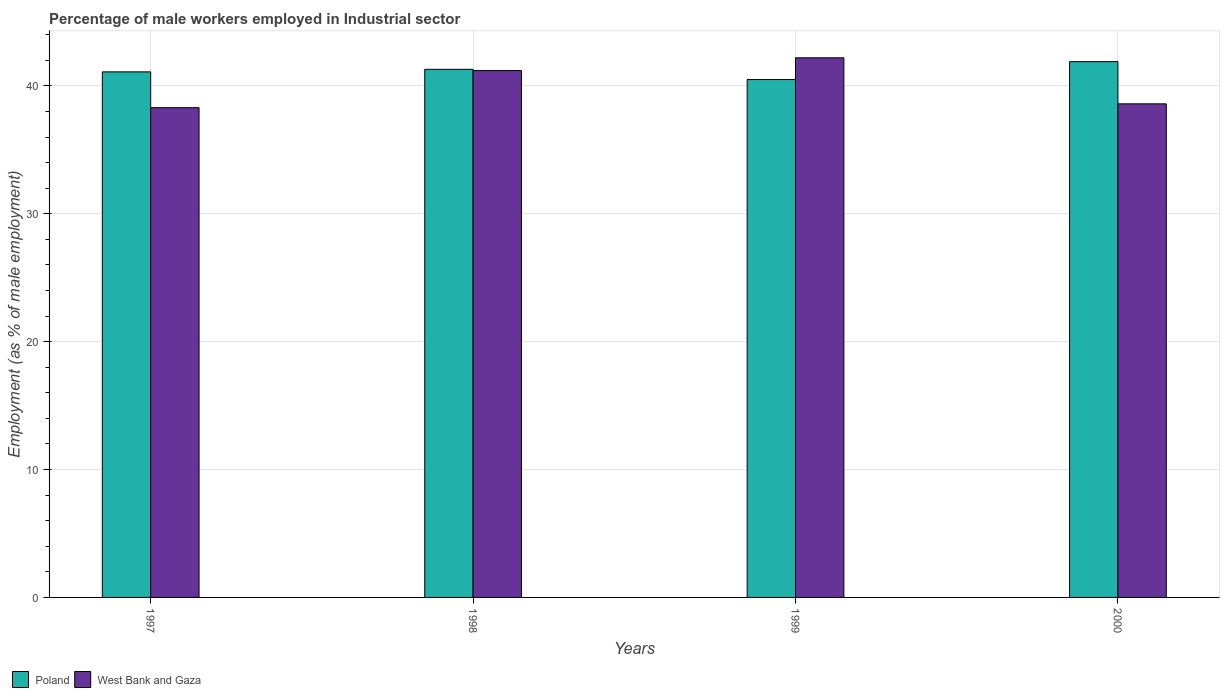Are the number of bars on each tick of the X-axis equal?
Offer a very short reply. Yes. How many bars are there on the 2nd tick from the left?
Give a very brief answer. 2. How many bars are there on the 3rd tick from the right?
Your answer should be compact. 2. In how many cases, is the number of bars for a given year not equal to the number of legend labels?
Your response must be concise. 0. What is the percentage of male workers employed in Industrial sector in West Bank and Gaza in 1999?
Provide a short and direct response. 42.2. Across all years, what is the maximum percentage of male workers employed in Industrial sector in West Bank and Gaza?
Your answer should be very brief. 42.2. Across all years, what is the minimum percentage of male workers employed in Industrial sector in West Bank and Gaza?
Give a very brief answer. 38.3. In which year was the percentage of male workers employed in Industrial sector in West Bank and Gaza maximum?
Make the answer very short. 1999. In which year was the percentage of male workers employed in Industrial sector in West Bank and Gaza minimum?
Keep it short and to the point. 1997. What is the total percentage of male workers employed in Industrial sector in West Bank and Gaza in the graph?
Make the answer very short. 160.3. What is the difference between the percentage of male workers employed in Industrial sector in West Bank and Gaza in 1999 and that in 2000?
Ensure brevity in your answer.  3.6. What is the difference between the percentage of male workers employed in Industrial sector in Poland in 1998 and the percentage of male workers employed in Industrial sector in West Bank and Gaza in 1997?
Ensure brevity in your answer.  3. What is the average percentage of male workers employed in Industrial sector in West Bank and Gaza per year?
Give a very brief answer. 40.07. In the year 2000, what is the difference between the percentage of male workers employed in Industrial sector in Poland and percentage of male workers employed in Industrial sector in West Bank and Gaza?
Your answer should be compact. 3.3. In how many years, is the percentage of male workers employed in Industrial sector in West Bank and Gaza greater than 14 %?
Make the answer very short. 4. What is the ratio of the percentage of male workers employed in Industrial sector in Poland in 1998 to that in 1999?
Provide a succinct answer. 1.02. Is the percentage of male workers employed in Industrial sector in Poland in 1997 less than that in 1998?
Offer a terse response. Yes. Is the difference between the percentage of male workers employed in Industrial sector in Poland in 1997 and 2000 greater than the difference between the percentage of male workers employed in Industrial sector in West Bank and Gaza in 1997 and 2000?
Keep it short and to the point. No. What is the difference between the highest and the lowest percentage of male workers employed in Industrial sector in West Bank and Gaza?
Give a very brief answer. 3.9. In how many years, is the percentage of male workers employed in Industrial sector in West Bank and Gaza greater than the average percentage of male workers employed in Industrial sector in West Bank and Gaza taken over all years?
Your response must be concise. 2. What does the 1st bar from the right in 1999 represents?
Keep it short and to the point. West Bank and Gaza. How many bars are there?
Your answer should be very brief. 8. Are all the bars in the graph horizontal?
Give a very brief answer. No. How many years are there in the graph?
Provide a short and direct response. 4. What is the difference between two consecutive major ticks on the Y-axis?
Your response must be concise. 10. Does the graph contain grids?
Provide a short and direct response. Yes. How are the legend labels stacked?
Your answer should be very brief. Horizontal. What is the title of the graph?
Your response must be concise. Percentage of male workers employed in Industrial sector. Does "San Marino" appear as one of the legend labels in the graph?
Provide a succinct answer. No. What is the label or title of the X-axis?
Keep it short and to the point. Years. What is the label or title of the Y-axis?
Ensure brevity in your answer.  Employment (as % of male employment). What is the Employment (as % of male employment) of Poland in 1997?
Your answer should be compact. 41.1. What is the Employment (as % of male employment) in West Bank and Gaza in 1997?
Give a very brief answer. 38.3. What is the Employment (as % of male employment) of Poland in 1998?
Offer a very short reply. 41.3. What is the Employment (as % of male employment) of West Bank and Gaza in 1998?
Provide a short and direct response. 41.2. What is the Employment (as % of male employment) of Poland in 1999?
Your response must be concise. 40.5. What is the Employment (as % of male employment) in West Bank and Gaza in 1999?
Give a very brief answer. 42.2. What is the Employment (as % of male employment) of Poland in 2000?
Your answer should be very brief. 41.9. What is the Employment (as % of male employment) in West Bank and Gaza in 2000?
Your answer should be very brief. 38.6. Across all years, what is the maximum Employment (as % of male employment) of Poland?
Provide a succinct answer. 41.9. Across all years, what is the maximum Employment (as % of male employment) in West Bank and Gaza?
Your response must be concise. 42.2. Across all years, what is the minimum Employment (as % of male employment) of Poland?
Your response must be concise. 40.5. Across all years, what is the minimum Employment (as % of male employment) in West Bank and Gaza?
Provide a succinct answer. 38.3. What is the total Employment (as % of male employment) of Poland in the graph?
Your response must be concise. 164.8. What is the total Employment (as % of male employment) in West Bank and Gaza in the graph?
Ensure brevity in your answer.  160.3. What is the difference between the Employment (as % of male employment) of Poland in 1997 and that in 1998?
Your answer should be compact. -0.2. What is the difference between the Employment (as % of male employment) in West Bank and Gaza in 1997 and that in 1999?
Your response must be concise. -3.9. What is the difference between the Employment (as % of male employment) of West Bank and Gaza in 1997 and that in 2000?
Ensure brevity in your answer.  -0.3. What is the difference between the Employment (as % of male employment) of West Bank and Gaza in 1998 and that in 1999?
Your answer should be very brief. -1. What is the difference between the Employment (as % of male employment) in West Bank and Gaza in 1999 and that in 2000?
Provide a succinct answer. 3.6. What is the difference between the Employment (as % of male employment) of Poland in 1997 and the Employment (as % of male employment) of West Bank and Gaza in 2000?
Provide a short and direct response. 2.5. What is the difference between the Employment (as % of male employment) of Poland in 1998 and the Employment (as % of male employment) of West Bank and Gaza in 2000?
Ensure brevity in your answer.  2.7. What is the difference between the Employment (as % of male employment) of Poland in 1999 and the Employment (as % of male employment) of West Bank and Gaza in 2000?
Offer a very short reply. 1.9. What is the average Employment (as % of male employment) of Poland per year?
Provide a short and direct response. 41.2. What is the average Employment (as % of male employment) of West Bank and Gaza per year?
Give a very brief answer. 40.08. In the year 1997, what is the difference between the Employment (as % of male employment) in Poland and Employment (as % of male employment) in West Bank and Gaza?
Ensure brevity in your answer.  2.8. In the year 1998, what is the difference between the Employment (as % of male employment) of Poland and Employment (as % of male employment) of West Bank and Gaza?
Keep it short and to the point. 0.1. In the year 1999, what is the difference between the Employment (as % of male employment) in Poland and Employment (as % of male employment) in West Bank and Gaza?
Your answer should be very brief. -1.7. What is the ratio of the Employment (as % of male employment) of Poland in 1997 to that in 1998?
Offer a terse response. 1. What is the ratio of the Employment (as % of male employment) of West Bank and Gaza in 1997 to that in 1998?
Offer a very short reply. 0.93. What is the ratio of the Employment (as % of male employment) of Poland in 1997 to that in 1999?
Offer a terse response. 1.01. What is the ratio of the Employment (as % of male employment) of West Bank and Gaza in 1997 to that in 1999?
Ensure brevity in your answer.  0.91. What is the ratio of the Employment (as % of male employment) in Poland in 1997 to that in 2000?
Offer a terse response. 0.98. What is the ratio of the Employment (as % of male employment) of Poland in 1998 to that in 1999?
Offer a terse response. 1.02. What is the ratio of the Employment (as % of male employment) in West Bank and Gaza in 1998 to that in 1999?
Give a very brief answer. 0.98. What is the ratio of the Employment (as % of male employment) in Poland in 1998 to that in 2000?
Your answer should be compact. 0.99. What is the ratio of the Employment (as % of male employment) in West Bank and Gaza in 1998 to that in 2000?
Provide a short and direct response. 1.07. What is the ratio of the Employment (as % of male employment) in Poland in 1999 to that in 2000?
Make the answer very short. 0.97. What is the ratio of the Employment (as % of male employment) of West Bank and Gaza in 1999 to that in 2000?
Provide a succinct answer. 1.09. What is the difference between the highest and the lowest Employment (as % of male employment) of Poland?
Ensure brevity in your answer.  1.4. 